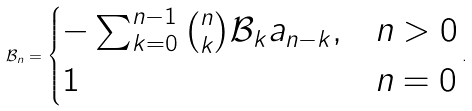Convert formula to latex. <formula><loc_0><loc_0><loc_500><loc_500>\mathcal { B } _ { n } = \begin{cases} - \sum _ { k = 0 } ^ { n - 1 } \binom { n } { k } \mathcal { B } _ { k } a _ { n - k } , & n > 0 \\ 1 & n = 0 \end{cases} .</formula> 